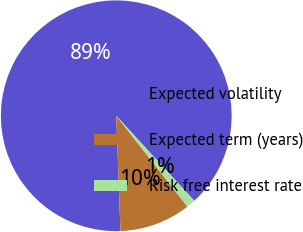Convert chart. <chart><loc_0><loc_0><loc_500><loc_500><pie_chart><fcel>Expected volatility<fcel>Expected term (years)<fcel>Risk free interest rate<nl><fcel>88.76%<fcel>10.0%<fcel>1.24%<nl></chart> 